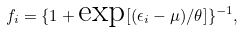Convert formula to latex. <formula><loc_0><loc_0><loc_500><loc_500>f _ { i } = \{ 1 + \text {exp} [ ( \epsilon _ { i } - \mu ) / \theta ] \} ^ { - 1 } ,</formula> 